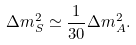Convert formula to latex. <formula><loc_0><loc_0><loc_500><loc_500>\Delta m ^ { 2 } _ { S } \simeq \frac { 1 } { 3 0 } \Delta m ^ { 2 } _ { A } .</formula> 